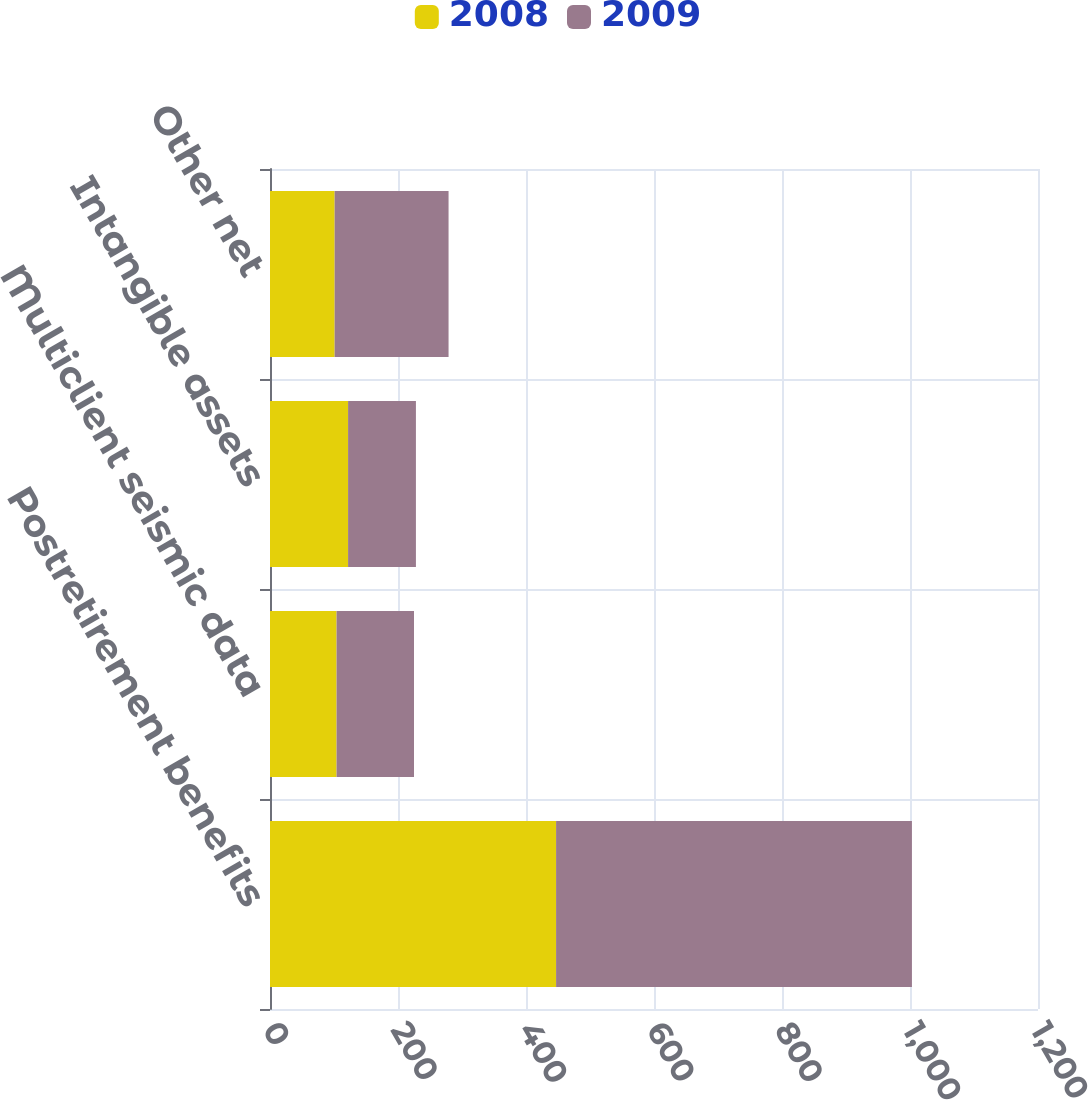Convert chart. <chart><loc_0><loc_0><loc_500><loc_500><stacked_bar_chart><ecel><fcel>Postretirement benefits<fcel>Multiclient seismic data<fcel>Intangible assets<fcel>Other net<nl><fcel>2008<fcel>447<fcel>104<fcel>122<fcel>101<nl><fcel>2009<fcel>556<fcel>121<fcel>106<fcel>178<nl></chart> 